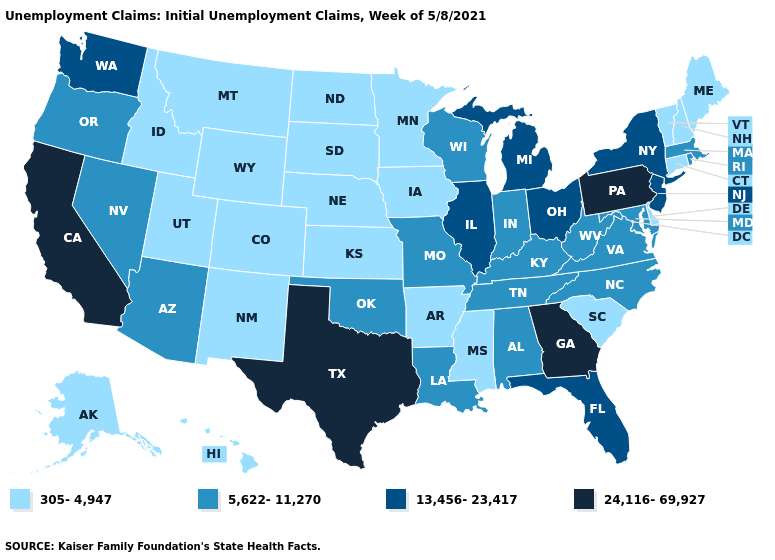Which states hav the highest value in the West?
Give a very brief answer. California. What is the value of Kansas?
Quick response, please. 305-4,947. What is the value of Ohio?
Write a very short answer. 13,456-23,417. Does the map have missing data?
Write a very short answer. No. What is the highest value in the MidWest ?
Answer briefly. 13,456-23,417. What is the value of Illinois?
Concise answer only. 13,456-23,417. What is the value of Arkansas?
Be succinct. 305-4,947. Name the states that have a value in the range 305-4,947?
Be succinct. Alaska, Arkansas, Colorado, Connecticut, Delaware, Hawaii, Idaho, Iowa, Kansas, Maine, Minnesota, Mississippi, Montana, Nebraska, New Hampshire, New Mexico, North Dakota, South Carolina, South Dakota, Utah, Vermont, Wyoming. Name the states that have a value in the range 5,622-11,270?
Quick response, please. Alabama, Arizona, Indiana, Kentucky, Louisiana, Maryland, Massachusetts, Missouri, Nevada, North Carolina, Oklahoma, Oregon, Rhode Island, Tennessee, Virginia, West Virginia, Wisconsin. Does New Hampshire have a higher value than Arkansas?
Concise answer only. No. Among the states that border Massachusetts , which have the lowest value?
Be succinct. Connecticut, New Hampshire, Vermont. Name the states that have a value in the range 5,622-11,270?
Answer briefly. Alabama, Arizona, Indiana, Kentucky, Louisiana, Maryland, Massachusetts, Missouri, Nevada, North Carolina, Oklahoma, Oregon, Rhode Island, Tennessee, Virginia, West Virginia, Wisconsin. Among the states that border North Carolina , which have the lowest value?
Give a very brief answer. South Carolina. Does Oregon have the same value as Ohio?
Answer briefly. No. 